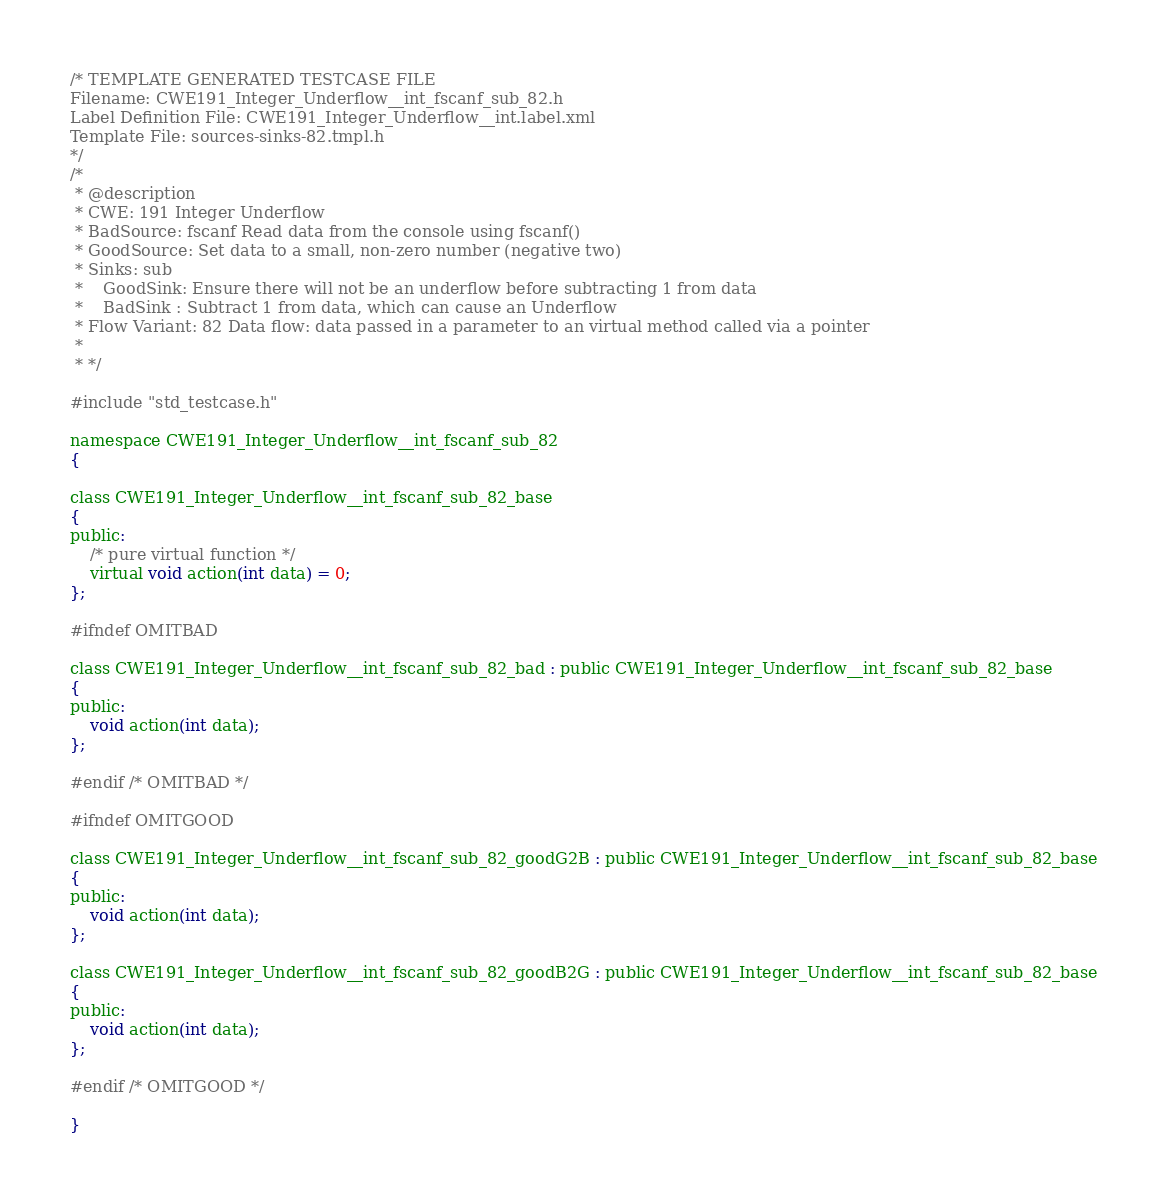<code> <loc_0><loc_0><loc_500><loc_500><_C_>/* TEMPLATE GENERATED TESTCASE FILE
Filename: CWE191_Integer_Underflow__int_fscanf_sub_82.h
Label Definition File: CWE191_Integer_Underflow__int.label.xml
Template File: sources-sinks-82.tmpl.h
*/
/*
 * @description
 * CWE: 191 Integer Underflow
 * BadSource: fscanf Read data from the console using fscanf()
 * GoodSource: Set data to a small, non-zero number (negative two)
 * Sinks: sub
 *    GoodSink: Ensure there will not be an underflow before subtracting 1 from data
 *    BadSink : Subtract 1 from data, which can cause an Underflow
 * Flow Variant: 82 Data flow: data passed in a parameter to an virtual method called via a pointer
 *
 * */

#include "std_testcase.h"

namespace CWE191_Integer_Underflow__int_fscanf_sub_82
{

class CWE191_Integer_Underflow__int_fscanf_sub_82_base
{
public:
    /* pure virtual function */
    virtual void action(int data) = 0;
};

#ifndef OMITBAD

class CWE191_Integer_Underflow__int_fscanf_sub_82_bad : public CWE191_Integer_Underflow__int_fscanf_sub_82_base
{
public:
    void action(int data);
};

#endif /* OMITBAD */

#ifndef OMITGOOD

class CWE191_Integer_Underflow__int_fscanf_sub_82_goodG2B : public CWE191_Integer_Underflow__int_fscanf_sub_82_base
{
public:
    void action(int data);
};

class CWE191_Integer_Underflow__int_fscanf_sub_82_goodB2G : public CWE191_Integer_Underflow__int_fscanf_sub_82_base
{
public:
    void action(int data);
};

#endif /* OMITGOOD */

}
</code> 